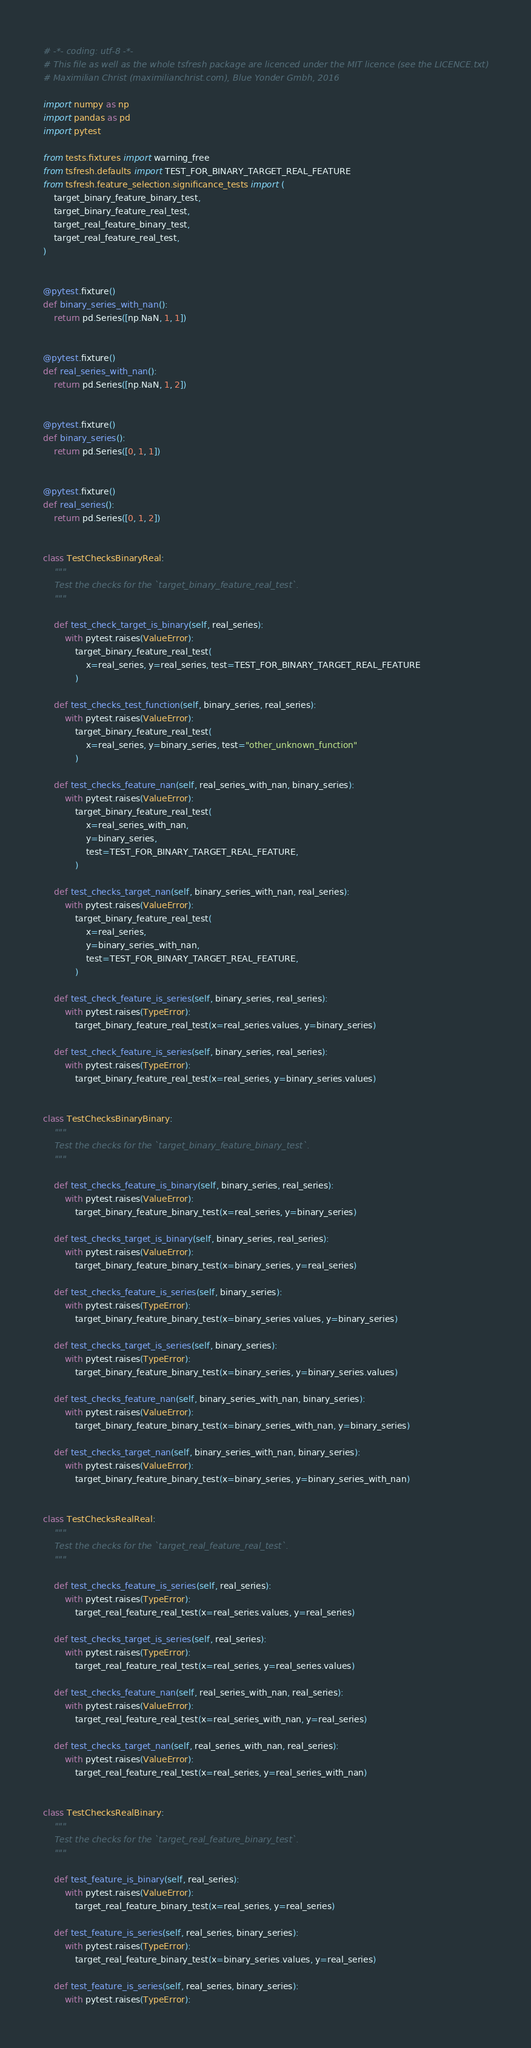Convert code to text. <code><loc_0><loc_0><loc_500><loc_500><_Python_># -*- coding: utf-8 -*-
# This file as well as the whole tsfresh package are licenced under the MIT licence (see the LICENCE.txt)
# Maximilian Christ (maximilianchrist.com), Blue Yonder Gmbh, 2016

import numpy as np
import pandas as pd
import pytest

from tests.fixtures import warning_free
from tsfresh.defaults import TEST_FOR_BINARY_TARGET_REAL_FEATURE
from tsfresh.feature_selection.significance_tests import (
    target_binary_feature_binary_test,
    target_binary_feature_real_test,
    target_real_feature_binary_test,
    target_real_feature_real_test,
)


@pytest.fixture()
def binary_series_with_nan():
    return pd.Series([np.NaN, 1, 1])


@pytest.fixture()
def real_series_with_nan():
    return pd.Series([np.NaN, 1, 2])


@pytest.fixture()
def binary_series():
    return pd.Series([0, 1, 1])


@pytest.fixture()
def real_series():
    return pd.Series([0, 1, 2])


class TestChecksBinaryReal:
    """
    Test the checks for the `target_binary_feature_real_test`.
    """

    def test_check_target_is_binary(self, real_series):
        with pytest.raises(ValueError):
            target_binary_feature_real_test(
                x=real_series, y=real_series, test=TEST_FOR_BINARY_TARGET_REAL_FEATURE
            )

    def test_checks_test_function(self, binary_series, real_series):
        with pytest.raises(ValueError):
            target_binary_feature_real_test(
                x=real_series, y=binary_series, test="other_unknown_function"
            )

    def test_checks_feature_nan(self, real_series_with_nan, binary_series):
        with pytest.raises(ValueError):
            target_binary_feature_real_test(
                x=real_series_with_nan,
                y=binary_series,
                test=TEST_FOR_BINARY_TARGET_REAL_FEATURE,
            )

    def test_checks_target_nan(self, binary_series_with_nan, real_series):
        with pytest.raises(ValueError):
            target_binary_feature_real_test(
                x=real_series,
                y=binary_series_with_nan,
                test=TEST_FOR_BINARY_TARGET_REAL_FEATURE,
            )

    def test_check_feature_is_series(self, binary_series, real_series):
        with pytest.raises(TypeError):
            target_binary_feature_real_test(x=real_series.values, y=binary_series)

    def test_check_feature_is_series(self, binary_series, real_series):
        with pytest.raises(TypeError):
            target_binary_feature_real_test(x=real_series, y=binary_series.values)


class TestChecksBinaryBinary:
    """
    Test the checks for the `target_binary_feature_binary_test`.
    """

    def test_checks_feature_is_binary(self, binary_series, real_series):
        with pytest.raises(ValueError):
            target_binary_feature_binary_test(x=real_series, y=binary_series)

    def test_checks_target_is_binary(self, binary_series, real_series):
        with pytest.raises(ValueError):
            target_binary_feature_binary_test(x=binary_series, y=real_series)

    def test_checks_feature_is_series(self, binary_series):
        with pytest.raises(TypeError):
            target_binary_feature_binary_test(x=binary_series.values, y=binary_series)

    def test_checks_target_is_series(self, binary_series):
        with pytest.raises(TypeError):
            target_binary_feature_binary_test(x=binary_series, y=binary_series.values)

    def test_checks_feature_nan(self, binary_series_with_nan, binary_series):
        with pytest.raises(ValueError):
            target_binary_feature_binary_test(x=binary_series_with_nan, y=binary_series)

    def test_checks_target_nan(self, binary_series_with_nan, binary_series):
        with pytest.raises(ValueError):
            target_binary_feature_binary_test(x=binary_series, y=binary_series_with_nan)


class TestChecksRealReal:
    """
    Test the checks for the `target_real_feature_real_test`.
    """

    def test_checks_feature_is_series(self, real_series):
        with pytest.raises(TypeError):
            target_real_feature_real_test(x=real_series.values, y=real_series)

    def test_checks_target_is_series(self, real_series):
        with pytest.raises(TypeError):
            target_real_feature_real_test(x=real_series, y=real_series.values)

    def test_checks_feature_nan(self, real_series_with_nan, real_series):
        with pytest.raises(ValueError):
            target_real_feature_real_test(x=real_series_with_nan, y=real_series)

    def test_checks_target_nan(self, real_series_with_nan, real_series):
        with pytest.raises(ValueError):
            target_real_feature_real_test(x=real_series, y=real_series_with_nan)


class TestChecksRealBinary:
    """
    Test the checks for the `target_real_feature_binary_test`.
    """

    def test_feature_is_binary(self, real_series):
        with pytest.raises(ValueError):
            target_real_feature_binary_test(x=real_series, y=real_series)

    def test_feature_is_series(self, real_series, binary_series):
        with pytest.raises(TypeError):
            target_real_feature_binary_test(x=binary_series.values, y=real_series)

    def test_feature_is_series(self, real_series, binary_series):
        with pytest.raises(TypeError):</code> 